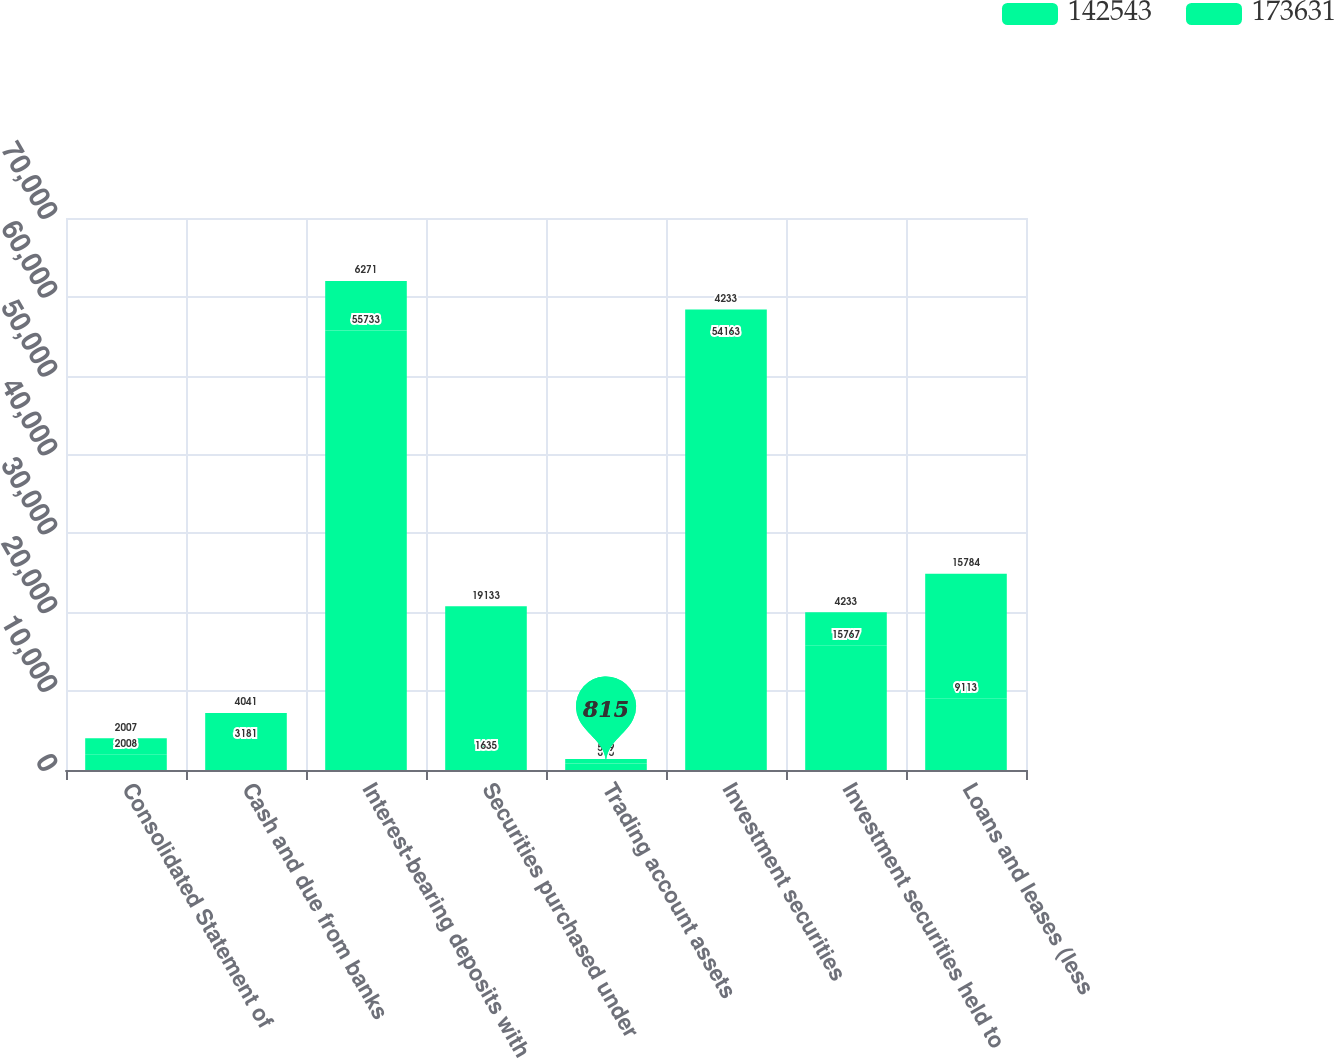Convert chart to OTSL. <chart><loc_0><loc_0><loc_500><loc_500><stacked_bar_chart><ecel><fcel>Consolidated Statement of<fcel>Cash and due from banks<fcel>Interest-bearing deposits with<fcel>Securities purchased under<fcel>Trading account assets<fcel>Investment securities<fcel>Investment securities held to<fcel>Loans and leases (less<nl><fcel>142543<fcel>2008<fcel>3181<fcel>55733<fcel>1635<fcel>815<fcel>54163<fcel>15767<fcel>9113<nl><fcel>173631<fcel>2007<fcel>4041<fcel>6271<fcel>19133<fcel>589<fcel>4233<fcel>4233<fcel>15784<nl></chart> 